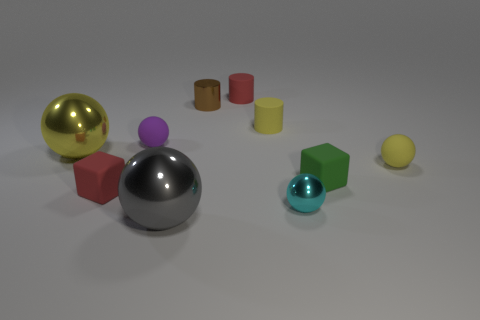Are there any rubber balls that have the same color as the small shiny cylinder?
Give a very brief answer. No. There is a purple ball that is made of the same material as the red block; what size is it?
Ensure brevity in your answer.  Small. Do the tiny red block and the tiny red cylinder have the same material?
Your response must be concise. Yes. What color is the block on the right side of the large metallic ball right of the cube that is to the left of the tiny purple object?
Make the answer very short. Green. What shape is the small purple matte thing?
Ensure brevity in your answer.  Sphere. Do the small shiny cylinder and the large metallic sphere to the left of the purple sphere have the same color?
Keep it short and to the point. No. Are there the same number of large balls to the left of the small purple rubber ball and tiny spheres?
Provide a succinct answer. No. How many brown metal things have the same size as the gray metal object?
Keep it short and to the point. 0. Are any tiny cyan shiny cylinders visible?
Keep it short and to the point. No. There is a small yellow rubber thing that is on the left side of the green object; is its shape the same as the small red object that is behind the brown cylinder?
Provide a short and direct response. Yes. 